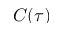<formula> <loc_0><loc_0><loc_500><loc_500>C ( \tau )</formula> 